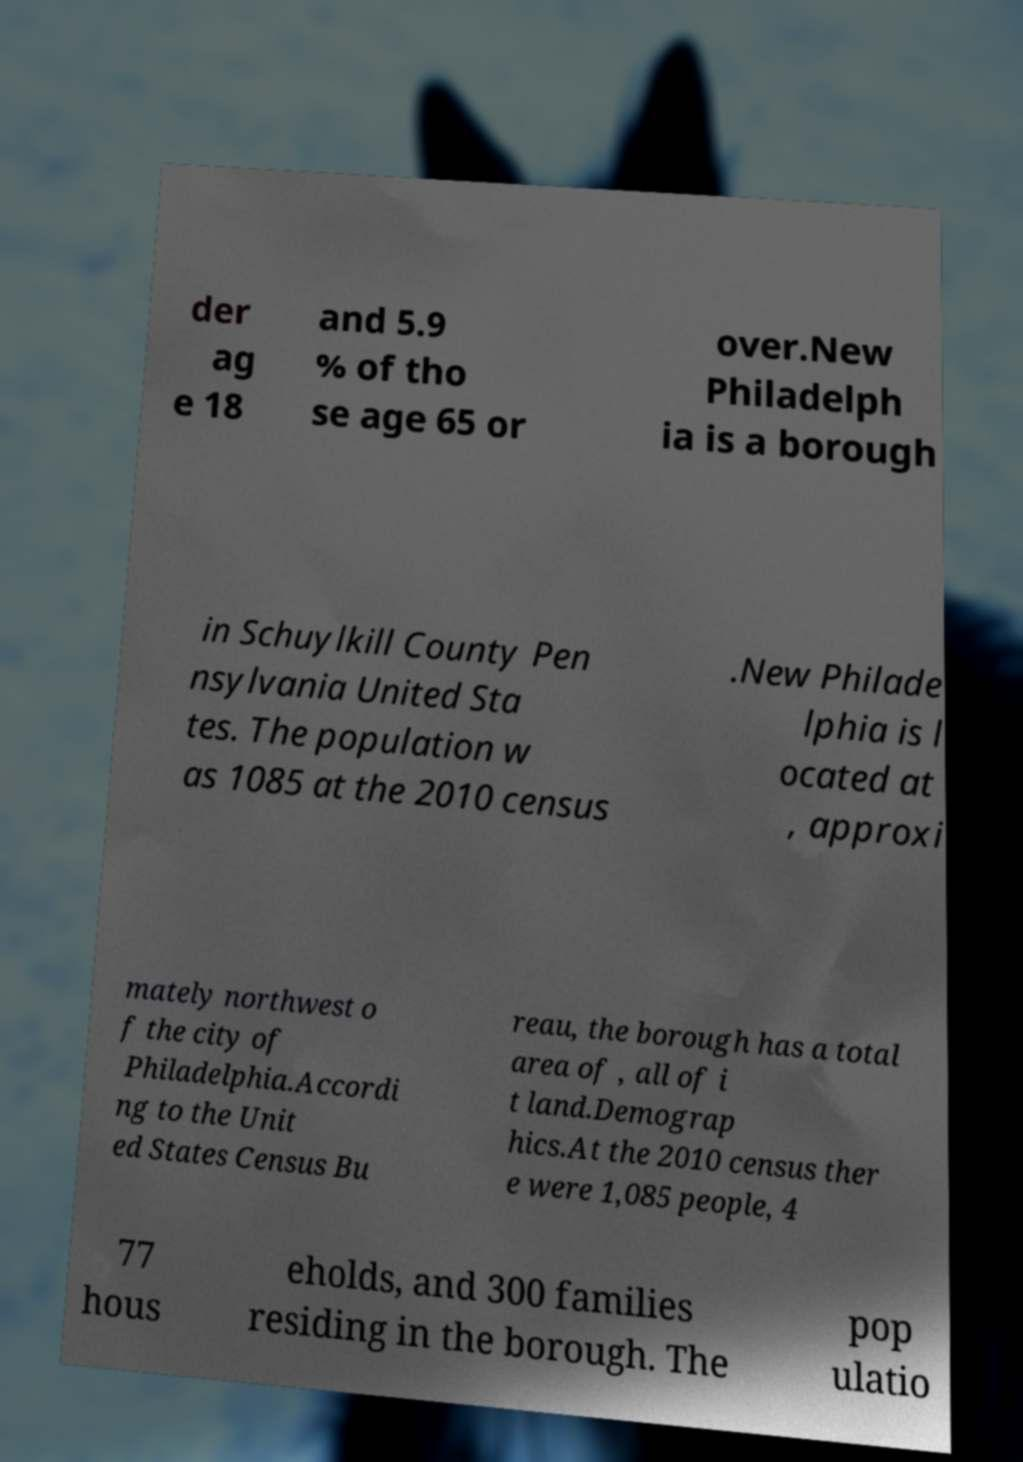Can you read and provide the text displayed in the image?This photo seems to have some interesting text. Can you extract and type it out for me? der ag e 18 and 5.9 % of tho se age 65 or over.New Philadelph ia is a borough in Schuylkill County Pen nsylvania United Sta tes. The population w as 1085 at the 2010 census .New Philade lphia is l ocated at , approxi mately northwest o f the city of Philadelphia.Accordi ng to the Unit ed States Census Bu reau, the borough has a total area of , all of i t land.Demograp hics.At the 2010 census ther e were 1,085 people, 4 77 hous eholds, and 300 families residing in the borough. The pop ulatio 